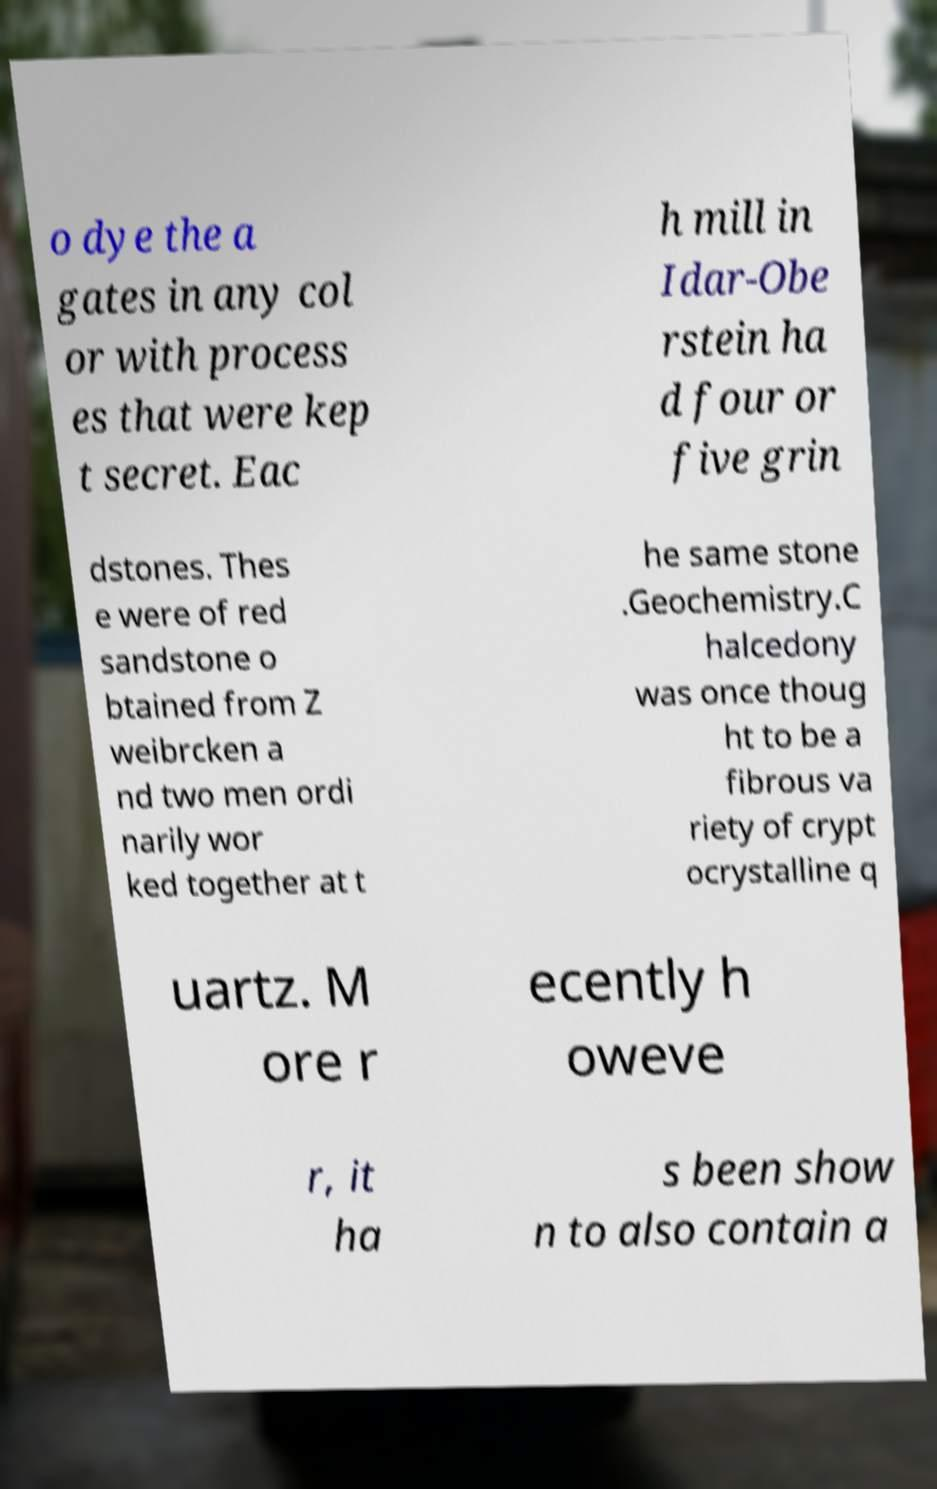What messages or text are displayed in this image? I need them in a readable, typed format. o dye the a gates in any col or with process es that were kep t secret. Eac h mill in Idar-Obe rstein ha d four or five grin dstones. Thes e were of red sandstone o btained from Z weibrcken a nd two men ordi narily wor ked together at t he same stone .Geochemistry.C halcedony was once thoug ht to be a fibrous va riety of crypt ocrystalline q uartz. M ore r ecently h oweve r, it ha s been show n to also contain a 